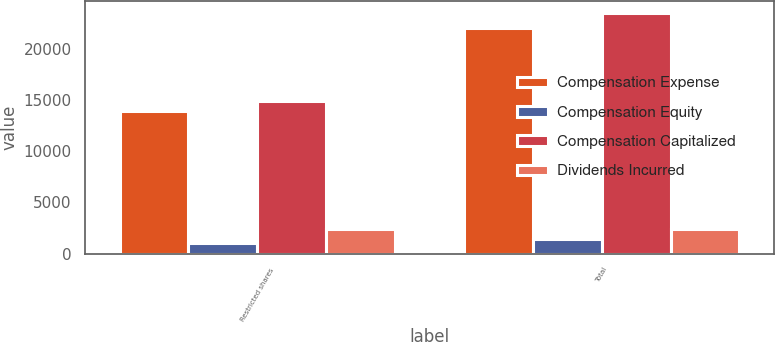Convert chart. <chart><loc_0><loc_0><loc_500><loc_500><stacked_bar_chart><ecel><fcel>Restricted shares<fcel>Total<nl><fcel>Compensation Expense<fcel>13923<fcel>22080<nl><fcel>Compensation Equity<fcel>1021<fcel>1435<nl><fcel>Compensation Capitalized<fcel>14944<fcel>23515<nl><fcel>Dividends Incurred<fcel>2437<fcel>2437<nl></chart> 